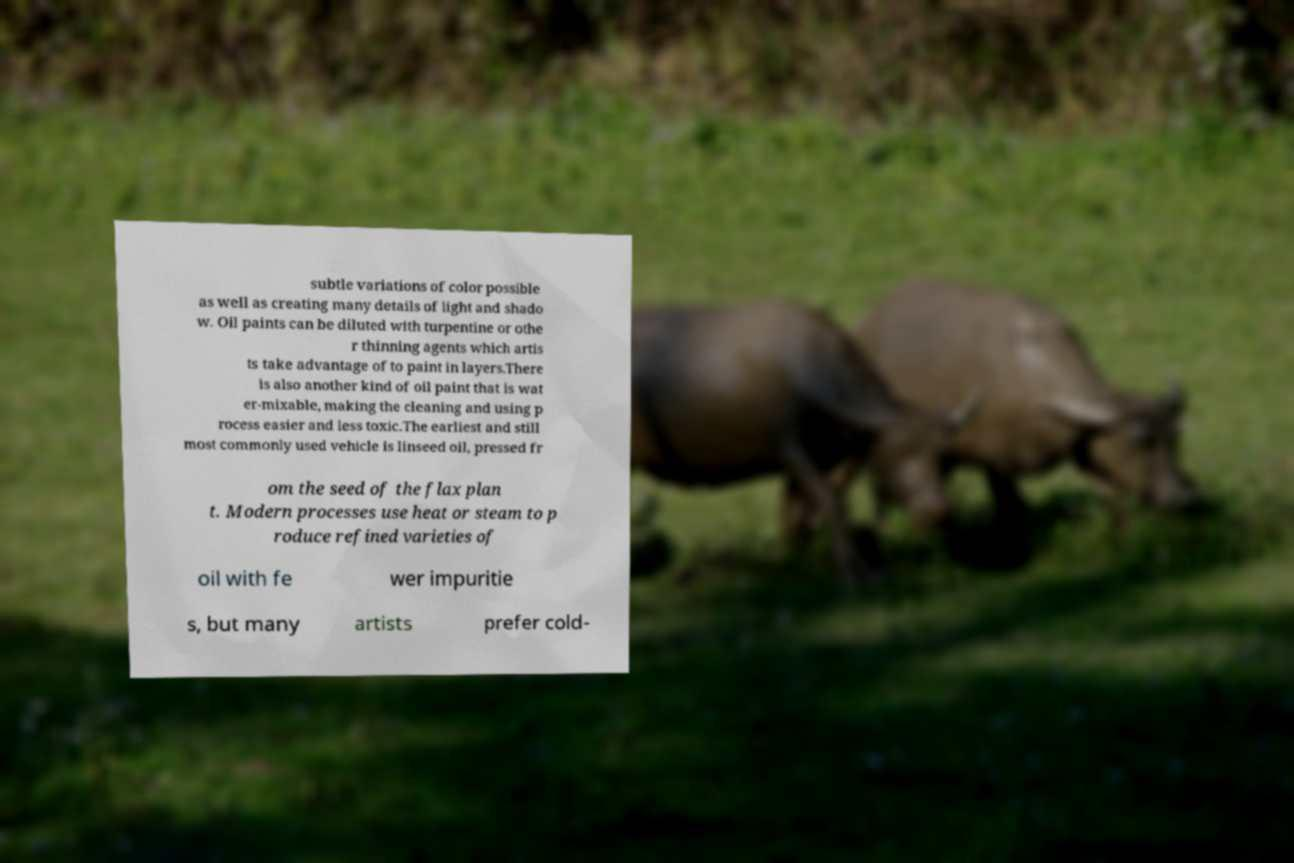Can you accurately transcribe the text from the provided image for me? subtle variations of color possible as well as creating many details of light and shado w. Oil paints can be diluted with turpentine or othe r thinning agents which artis ts take advantage of to paint in layers.There is also another kind of oil paint that is wat er-mixable, making the cleaning and using p rocess easier and less toxic.The earliest and still most commonly used vehicle is linseed oil, pressed fr om the seed of the flax plan t. Modern processes use heat or steam to p roduce refined varieties of oil with fe wer impuritie s, but many artists prefer cold- 